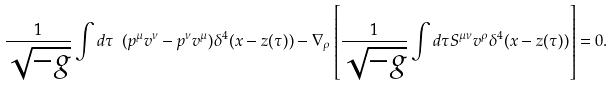<formula> <loc_0><loc_0><loc_500><loc_500>\frac { 1 } { \sqrt { - g } } \int d \tau \ ( p ^ { \mu } v ^ { \nu } - p ^ { \nu } v ^ { \mu } ) \delta ^ { 4 } ( x - z ( \tau ) ) - \nabla _ { \rho } \left [ \frac { 1 } { \sqrt { - g } } \int d \tau S ^ { \mu \nu } v ^ { \rho } \delta ^ { 4 } ( x - z ( \tau ) ) \right ] = 0 .</formula> 